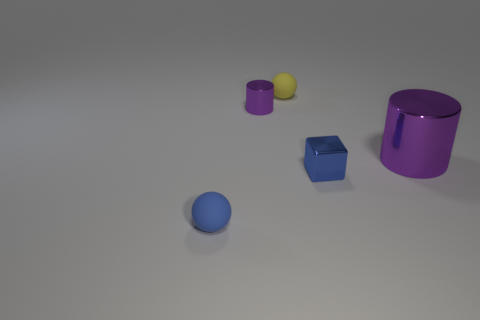Add 3 big cylinders. How many objects exist? 8 Subtract all cylinders. How many objects are left? 3 Subtract 0 brown spheres. How many objects are left? 5 Subtract all tiny blue matte things. Subtract all big purple things. How many objects are left? 3 Add 1 purple things. How many purple things are left? 3 Add 5 big red spheres. How many big red spheres exist? 5 